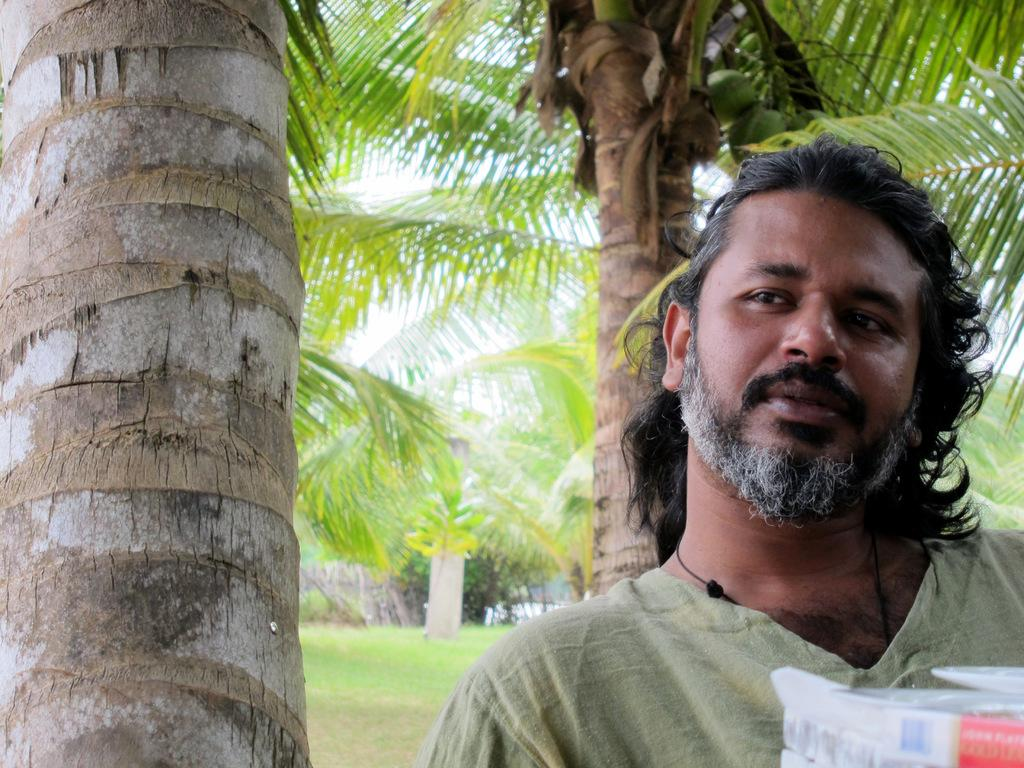Who or what is the main subject in the image? There is a person in the image. What can be seen in the bottom right corner of the image? There are a few things in the bottom right of the image. What type of natural environment is visible in the image? There is grass visible in the image, and there are also trees present. What other objects can be seen in the image besides the person and the things in the bottom right corner? There are other objects in the image. What is visible in the background of the image? The sky is visible in the image. What time does the clock in the image show? There is no clock present in the image. How does the person in the image respond to the cough? There is no coughing person or any indication of a cough in the image. 